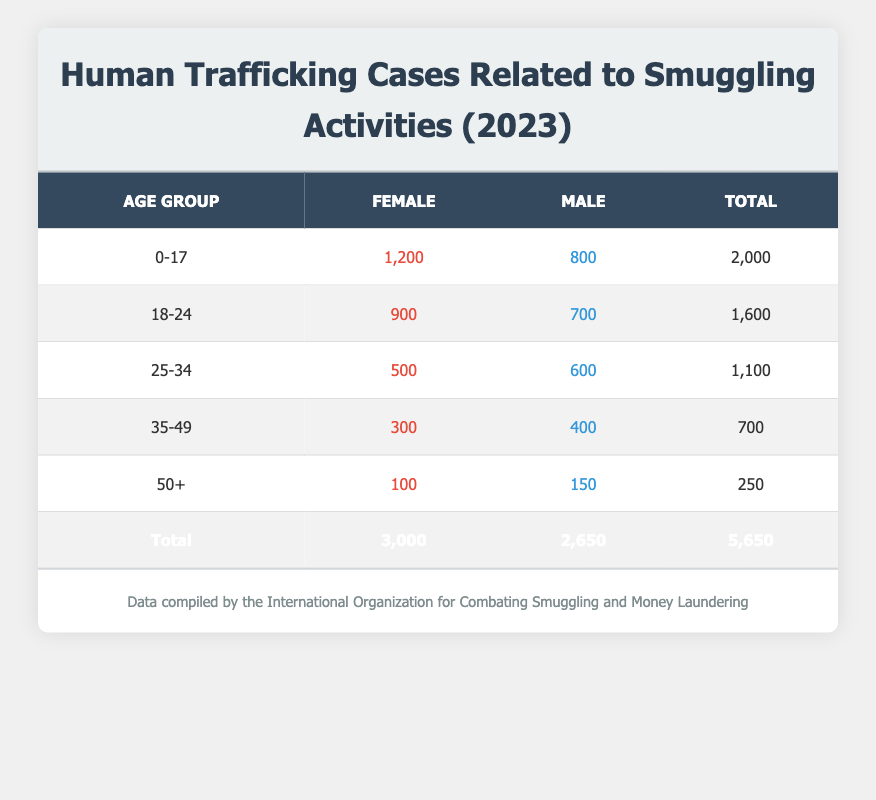What is the total number of reported human trafficking cases for the age group 0-17? The table shows the total reported cases for the age group 0-17 as 2000, which is the sum of cases for both females (1200) and males (800).
Answer: 2000 How many more reported cases were there for females in the age group 18-24 compared to males? For the age group 18-24, there are 900 reported cases for females and 700 for males. The difference is 900 - 700 = 200 cases, meaning there are 200 more reported cases for females.
Answer: 200 What is the total number of reported cases for all genders across all age groups? To find the total, we sum the total cases in each row: 2000 (0-17) + 1600 (18-24) + 1100 (25-34) + 700 (35-49) + 250 (50+) = 5650.
Answer: 5650 Is the total number of reported cases for males higher than that for females? The total for males is 2650 (sum of males in each age group) and for females is 3000. Since 2650 is less than 3000, the statement is false.
Answer: No What is the average number of reported cases for the age group 25-34? For the age group 25-34, the reported cases are 500 for females and 600 for males, totaling 1100 cases. The average, when considering both genders, is 1100 / 2 = 550.
Answer: 550 Which age group has the highest number of reported cases and what is that number? The age group 0-17 has the highest number of cases with a total of 2000, which is higher than the other age groups when the totals are compared.
Answer: 2000 How many reported cases were recorded for males aged 35-49? According to the table, there are 400 reported cases for males in the age group 35-49, as listed directly in that row.
Answer: 400 What percentage of total cases do the older age groups (35-49 and 50+) represent compared to the overall total? The total cases for age groups 35-49 and 50+ are 700 (35-49) + 250 (50+) = 950. The overall total is 5650. The percentage is (950 / 5650) * 100 = 16.8%.
Answer: 16.8% 